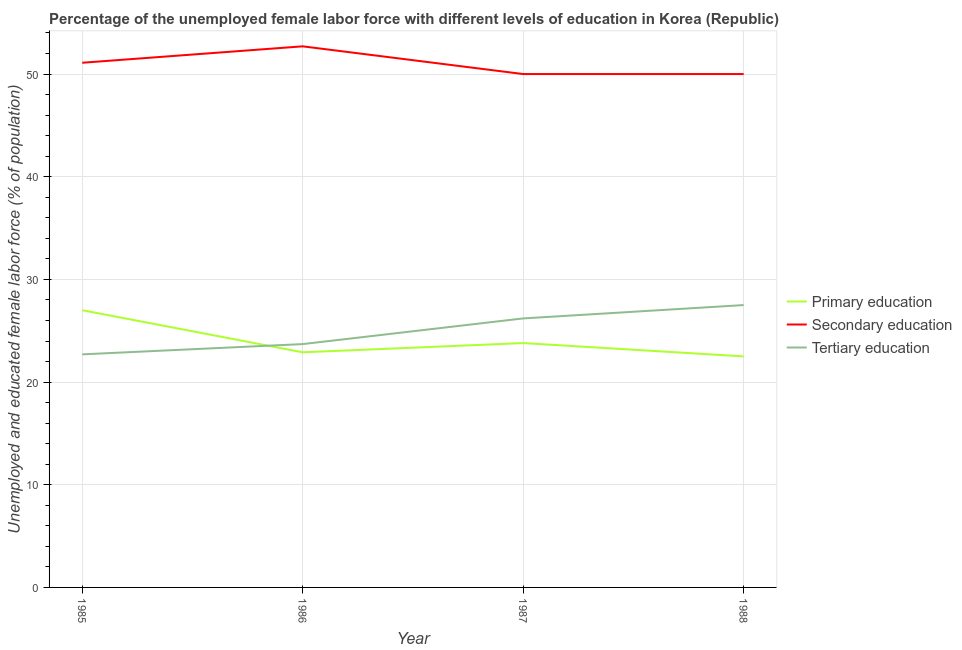How many different coloured lines are there?
Your answer should be compact. 3. Across all years, what is the minimum percentage of female labor force who received secondary education?
Offer a very short reply. 50. What is the total percentage of female labor force who received primary education in the graph?
Offer a terse response. 96.2. What is the difference between the percentage of female labor force who received secondary education in 1986 and that in 1988?
Ensure brevity in your answer.  2.7. What is the average percentage of female labor force who received primary education per year?
Provide a succinct answer. 24.05. In the year 1988, what is the difference between the percentage of female labor force who received tertiary education and percentage of female labor force who received primary education?
Give a very brief answer. 5. What is the ratio of the percentage of female labor force who received secondary education in 1985 to that in 1987?
Offer a very short reply. 1.02. Is the percentage of female labor force who received secondary education in 1987 less than that in 1988?
Make the answer very short. No. Is the difference between the percentage of female labor force who received tertiary education in 1987 and 1988 greater than the difference between the percentage of female labor force who received secondary education in 1987 and 1988?
Provide a succinct answer. No. What is the difference between the highest and the second highest percentage of female labor force who received secondary education?
Provide a succinct answer. 1.6. What is the difference between the highest and the lowest percentage of female labor force who received tertiary education?
Your answer should be compact. 4.8. In how many years, is the percentage of female labor force who received secondary education greater than the average percentage of female labor force who received secondary education taken over all years?
Offer a very short reply. 2. Is it the case that in every year, the sum of the percentage of female labor force who received primary education and percentage of female labor force who received secondary education is greater than the percentage of female labor force who received tertiary education?
Ensure brevity in your answer.  Yes. Does the percentage of female labor force who received tertiary education monotonically increase over the years?
Offer a terse response. Yes. Is the percentage of female labor force who received secondary education strictly less than the percentage of female labor force who received primary education over the years?
Offer a very short reply. No. What is the difference between two consecutive major ticks on the Y-axis?
Keep it short and to the point. 10. Are the values on the major ticks of Y-axis written in scientific E-notation?
Provide a succinct answer. No. Does the graph contain grids?
Keep it short and to the point. Yes. What is the title of the graph?
Provide a succinct answer. Percentage of the unemployed female labor force with different levels of education in Korea (Republic). Does "Refusal of sex" appear as one of the legend labels in the graph?
Ensure brevity in your answer.  No. What is the label or title of the Y-axis?
Offer a terse response. Unemployed and educated female labor force (% of population). What is the Unemployed and educated female labor force (% of population) in Primary education in 1985?
Keep it short and to the point. 27. What is the Unemployed and educated female labor force (% of population) in Secondary education in 1985?
Your answer should be compact. 51.1. What is the Unemployed and educated female labor force (% of population) of Tertiary education in 1985?
Offer a very short reply. 22.7. What is the Unemployed and educated female labor force (% of population) of Primary education in 1986?
Offer a terse response. 22.9. What is the Unemployed and educated female labor force (% of population) in Secondary education in 1986?
Your response must be concise. 52.7. What is the Unemployed and educated female labor force (% of population) in Tertiary education in 1986?
Your response must be concise. 23.7. What is the Unemployed and educated female labor force (% of population) of Primary education in 1987?
Make the answer very short. 23.8. What is the Unemployed and educated female labor force (% of population) in Tertiary education in 1987?
Keep it short and to the point. 26.2. What is the Unemployed and educated female labor force (% of population) of Secondary education in 1988?
Provide a short and direct response. 50. What is the Unemployed and educated female labor force (% of population) in Tertiary education in 1988?
Keep it short and to the point. 27.5. Across all years, what is the maximum Unemployed and educated female labor force (% of population) of Secondary education?
Offer a terse response. 52.7. Across all years, what is the minimum Unemployed and educated female labor force (% of population) of Primary education?
Offer a very short reply. 22.5. Across all years, what is the minimum Unemployed and educated female labor force (% of population) of Tertiary education?
Make the answer very short. 22.7. What is the total Unemployed and educated female labor force (% of population) in Primary education in the graph?
Your response must be concise. 96.2. What is the total Unemployed and educated female labor force (% of population) of Secondary education in the graph?
Give a very brief answer. 203.8. What is the total Unemployed and educated female labor force (% of population) in Tertiary education in the graph?
Keep it short and to the point. 100.1. What is the difference between the Unemployed and educated female labor force (% of population) in Primary education in 1985 and that in 1986?
Give a very brief answer. 4.1. What is the difference between the Unemployed and educated female labor force (% of population) in Secondary education in 1985 and that in 1986?
Ensure brevity in your answer.  -1.6. What is the difference between the Unemployed and educated female labor force (% of population) in Tertiary education in 1985 and that in 1986?
Offer a very short reply. -1. What is the difference between the Unemployed and educated female labor force (% of population) of Primary education in 1985 and that in 1987?
Your answer should be very brief. 3.2. What is the difference between the Unemployed and educated female labor force (% of population) in Secondary education in 1985 and that in 1988?
Your response must be concise. 1.1. What is the difference between the Unemployed and educated female labor force (% of population) of Primary education in 1986 and that in 1987?
Ensure brevity in your answer.  -0.9. What is the difference between the Unemployed and educated female labor force (% of population) of Secondary education in 1986 and that in 1987?
Provide a succinct answer. 2.7. What is the difference between the Unemployed and educated female labor force (% of population) of Tertiary education in 1986 and that in 1987?
Your response must be concise. -2.5. What is the difference between the Unemployed and educated female labor force (% of population) of Primary education in 1986 and that in 1988?
Make the answer very short. 0.4. What is the difference between the Unemployed and educated female labor force (% of population) in Secondary education in 1986 and that in 1988?
Provide a short and direct response. 2.7. What is the difference between the Unemployed and educated female labor force (% of population) in Secondary education in 1987 and that in 1988?
Your response must be concise. 0. What is the difference between the Unemployed and educated female labor force (% of population) of Tertiary education in 1987 and that in 1988?
Keep it short and to the point. -1.3. What is the difference between the Unemployed and educated female labor force (% of population) of Primary education in 1985 and the Unemployed and educated female labor force (% of population) of Secondary education in 1986?
Offer a terse response. -25.7. What is the difference between the Unemployed and educated female labor force (% of population) of Primary education in 1985 and the Unemployed and educated female labor force (% of population) of Tertiary education in 1986?
Your response must be concise. 3.3. What is the difference between the Unemployed and educated female labor force (% of population) of Secondary education in 1985 and the Unemployed and educated female labor force (% of population) of Tertiary education in 1986?
Give a very brief answer. 27.4. What is the difference between the Unemployed and educated female labor force (% of population) of Primary education in 1985 and the Unemployed and educated female labor force (% of population) of Secondary education in 1987?
Offer a terse response. -23. What is the difference between the Unemployed and educated female labor force (% of population) of Primary education in 1985 and the Unemployed and educated female labor force (% of population) of Tertiary education in 1987?
Ensure brevity in your answer.  0.8. What is the difference between the Unemployed and educated female labor force (% of population) of Secondary education in 1985 and the Unemployed and educated female labor force (% of population) of Tertiary education in 1987?
Your answer should be compact. 24.9. What is the difference between the Unemployed and educated female labor force (% of population) of Primary education in 1985 and the Unemployed and educated female labor force (% of population) of Secondary education in 1988?
Make the answer very short. -23. What is the difference between the Unemployed and educated female labor force (% of population) of Secondary education in 1985 and the Unemployed and educated female labor force (% of population) of Tertiary education in 1988?
Your response must be concise. 23.6. What is the difference between the Unemployed and educated female labor force (% of population) in Primary education in 1986 and the Unemployed and educated female labor force (% of population) in Secondary education in 1987?
Make the answer very short. -27.1. What is the difference between the Unemployed and educated female labor force (% of population) of Primary education in 1986 and the Unemployed and educated female labor force (% of population) of Tertiary education in 1987?
Your answer should be compact. -3.3. What is the difference between the Unemployed and educated female labor force (% of population) in Secondary education in 1986 and the Unemployed and educated female labor force (% of population) in Tertiary education in 1987?
Provide a succinct answer. 26.5. What is the difference between the Unemployed and educated female labor force (% of population) in Primary education in 1986 and the Unemployed and educated female labor force (% of population) in Secondary education in 1988?
Make the answer very short. -27.1. What is the difference between the Unemployed and educated female labor force (% of population) in Secondary education in 1986 and the Unemployed and educated female labor force (% of population) in Tertiary education in 1988?
Offer a very short reply. 25.2. What is the difference between the Unemployed and educated female labor force (% of population) of Primary education in 1987 and the Unemployed and educated female labor force (% of population) of Secondary education in 1988?
Provide a succinct answer. -26.2. What is the difference between the Unemployed and educated female labor force (% of population) in Primary education in 1987 and the Unemployed and educated female labor force (% of population) in Tertiary education in 1988?
Give a very brief answer. -3.7. What is the difference between the Unemployed and educated female labor force (% of population) in Secondary education in 1987 and the Unemployed and educated female labor force (% of population) in Tertiary education in 1988?
Your answer should be compact. 22.5. What is the average Unemployed and educated female labor force (% of population) of Primary education per year?
Your answer should be very brief. 24.05. What is the average Unemployed and educated female labor force (% of population) in Secondary education per year?
Give a very brief answer. 50.95. What is the average Unemployed and educated female labor force (% of population) of Tertiary education per year?
Ensure brevity in your answer.  25.02. In the year 1985, what is the difference between the Unemployed and educated female labor force (% of population) of Primary education and Unemployed and educated female labor force (% of population) of Secondary education?
Keep it short and to the point. -24.1. In the year 1985, what is the difference between the Unemployed and educated female labor force (% of population) in Primary education and Unemployed and educated female labor force (% of population) in Tertiary education?
Provide a short and direct response. 4.3. In the year 1985, what is the difference between the Unemployed and educated female labor force (% of population) of Secondary education and Unemployed and educated female labor force (% of population) of Tertiary education?
Ensure brevity in your answer.  28.4. In the year 1986, what is the difference between the Unemployed and educated female labor force (% of population) of Primary education and Unemployed and educated female labor force (% of population) of Secondary education?
Make the answer very short. -29.8. In the year 1986, what is the difference between the Unemployed and educated female labor force (% of population) in Primary education and Unemployed and educated female labor force (% of population) in Tertiary education?
Offer a very short reply. -0.8. In the year 1986, what is the difference between the Unemployed and educated female labor force (% of population) in Secondary education and Unemployed and educated female labor force (% of population) in Tertiary education?
Ensure brevity in your answer.  29. In the year 1987, what is the difference between the Unemployed and educated female labor force (% of population) in Primary education and Unemployed and educated female labor force (% of population) in Secondary education?
Your response must be concise. -26.2. In the year 1987, what is the difference between the Unemployed and educated female labor force (% of population) in Primary education and Unemployed and educated female labor force (% of population) in Tertiary education?
Your answer should be very brief. -2.4. In the year 1987, what is the difference between the Unemployed and educated female labor force (% of population) in Secondary education and Unemployed and educated female labor force (% of population) in Tertiary education?
Your answer should be very brief. 23.8. In the year 1988, what is the difference between the Unemployed and educated female labor force (% of population) in Primary education and Unemployed and educated female labor force (% of population) in Secondary education?
Keep it short and to the point. -27.5. In the year 1988, what is the difference between the Unemployed and educated female labor force (% of population) in Primary education and Unemployed and educated female labor force (% of population) in Tertiary education?
Provide a short and direct response. -5. What is the ratio of the Unemployed and educated female labor force (% of population) in Primary education in 1985 to that in 1986?
Make the answer very short. 1.18. What is the ratio of the Unemployed and educated female labor force (% of population) in Secondary education in 1985 to that in 1986?
Offer a terse response. 0.97. What is the ratio of the Unemployed and educated female labor force (% of population) in Tertiary education in 1985 to that in 1986?
Provide a succinct answer. 0.96. What is the ratio of the Unemployed and educated female labor force (% of population) in Primary education in 1985 to that in 1987?
Make the answer very short. 1.13. What is the ratio of the Unemployed and educated female labor force (% of population) of Tertiary education in 1985 to that in 1987?
Your answer should be compact. 0.87. What is the ratio of the Unemployed and educated female labor force (% of population) in Primary education in 1985 to that in 1988?
Give a very brief answer. 1.2. What is the ratio of the Unemployed and educated female labor force (% of population) of Secondary education in 1985 to that in 1988?
Offer a very short reply. 1.02. What is the ratio of the Unemployed and educated female labor force (% of population) of Tertiary education in 1985 to that in 1988?
Your answer should be compact. 0.83. What is the ratio of the Unemployed and educated female labor force (% of population) in Primary education in 1986 to that in 1987?
Your answer should be compact. 0.96. What is the ratio of the Unemployed and educated female labor force (% of population) of Secondary education in 1986 to that in 1987?
Offer a terse response. 1.05. What is the ratio of the Unemployed and educated female labor force (% of population) in Tertiary education in 1986 to that in 1987?
Your answer should be very brief. 0.9. What is the ratio of the Unemployed and educated female labor force (% of population) of Primary education in 1986 to that in 1988?
Provide a short and direct response. 1.02. What is the ratio of the Unemployed and educated female labor force (% of population) of Secondary education in 1986 to that in 1988?
Offer a very short reply. 1.05. What is the ratio of the Unemployed and educated female labor force (% of population) in Tertiary education in 1986 to that in 1988?
Keep it short and to the point. 0.86. What is the ratio of the Unemployed and educated female labor force (% of population) of Primary education in 1987 to that in 1988?
Your answer should be compact. 1.06. What is the ratio of the Unemployed and educated female labor force (% of population) in Secondary education in 1987 to that in 1988?
Offer a terse response. 1. What is the ratio of the Unemployed and educated female labor force (% of population) in Tertiary education in 1987 to that in 1988?
Your answer should be compact. 0.95. What is the difference between the highest and the second highest Unemployed and educated female labor force (% of population) in Tertiary education?
Provide a succinct answer. 1.3. What is the difference between the highest and the lowest Unemployed and educated female labor force (% of population) in Tertiary education?
Ensure brevity in your answer.  4.8. 